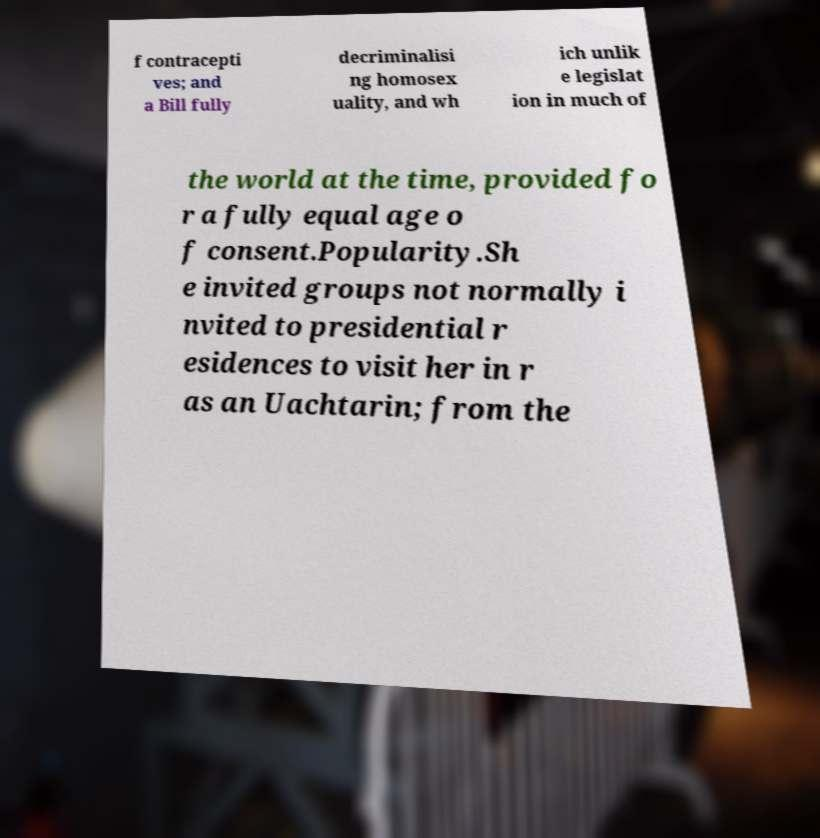There's text embedded in this image that I need extracted. Can you transcribe it verbatim? f contracepti ves; and a Bill fully decriminalisi ng homosex uality, and wh ich unlik e legislat ion in much of the world at the time, provided fo r a fully equal age o f consent.Popularity.Sh e invited groups not normally i nvited to presidential r esidences to visit her in r as an Uachtarin; from the 